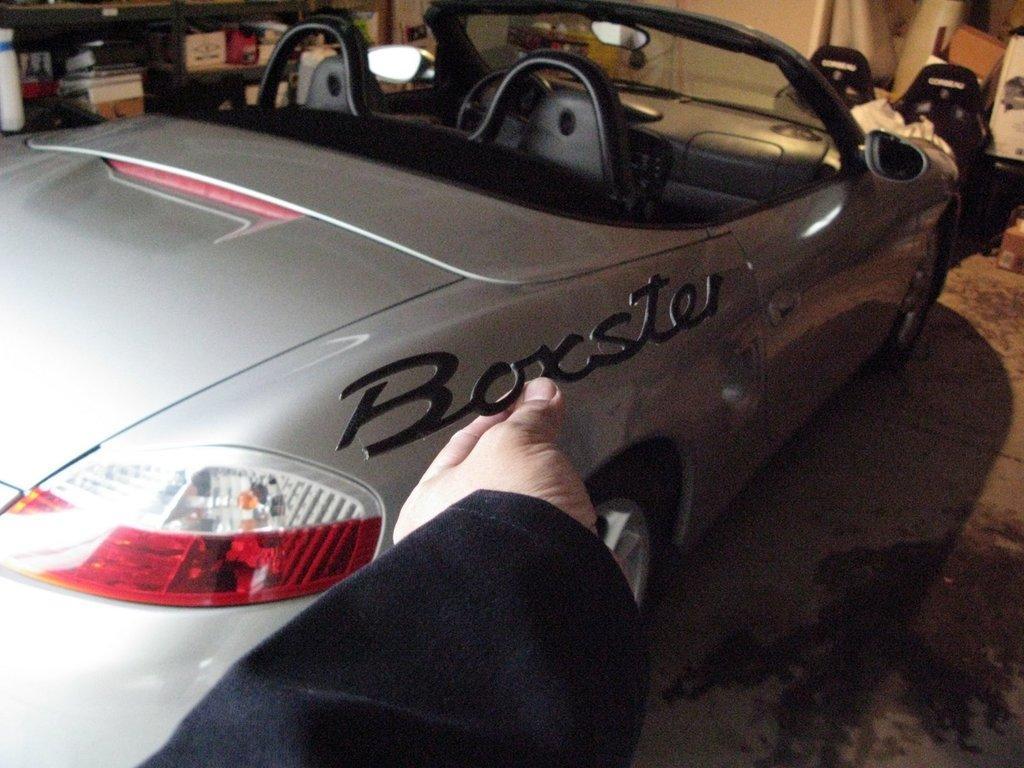Please provide a concise description of this image. In this image there is a person holding a vehicle name plate , and there is a car, cardboard boxes and some objects in the racks. 